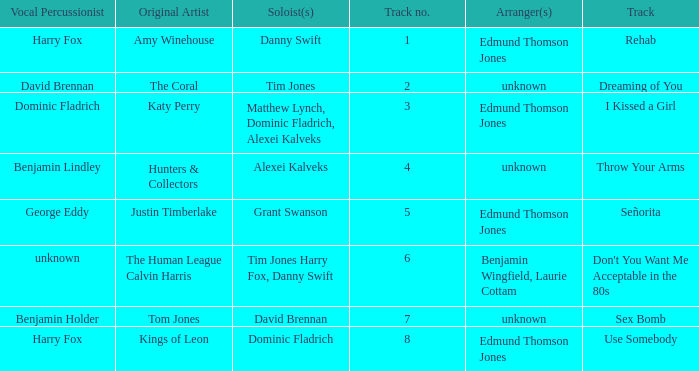Who is the original artist of "Use Somebody"? Kings of Leon. 